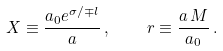Convert formula to latex. <formula><loc_0><loc_0><loc_500><loc_500>X \equiv \frac { a _ { 0 } e ^ { \sigma / \mp l } } { a } \, , \quad r \equiv \frac { a \, M } { a _ { 0 } } \, .</formula> 